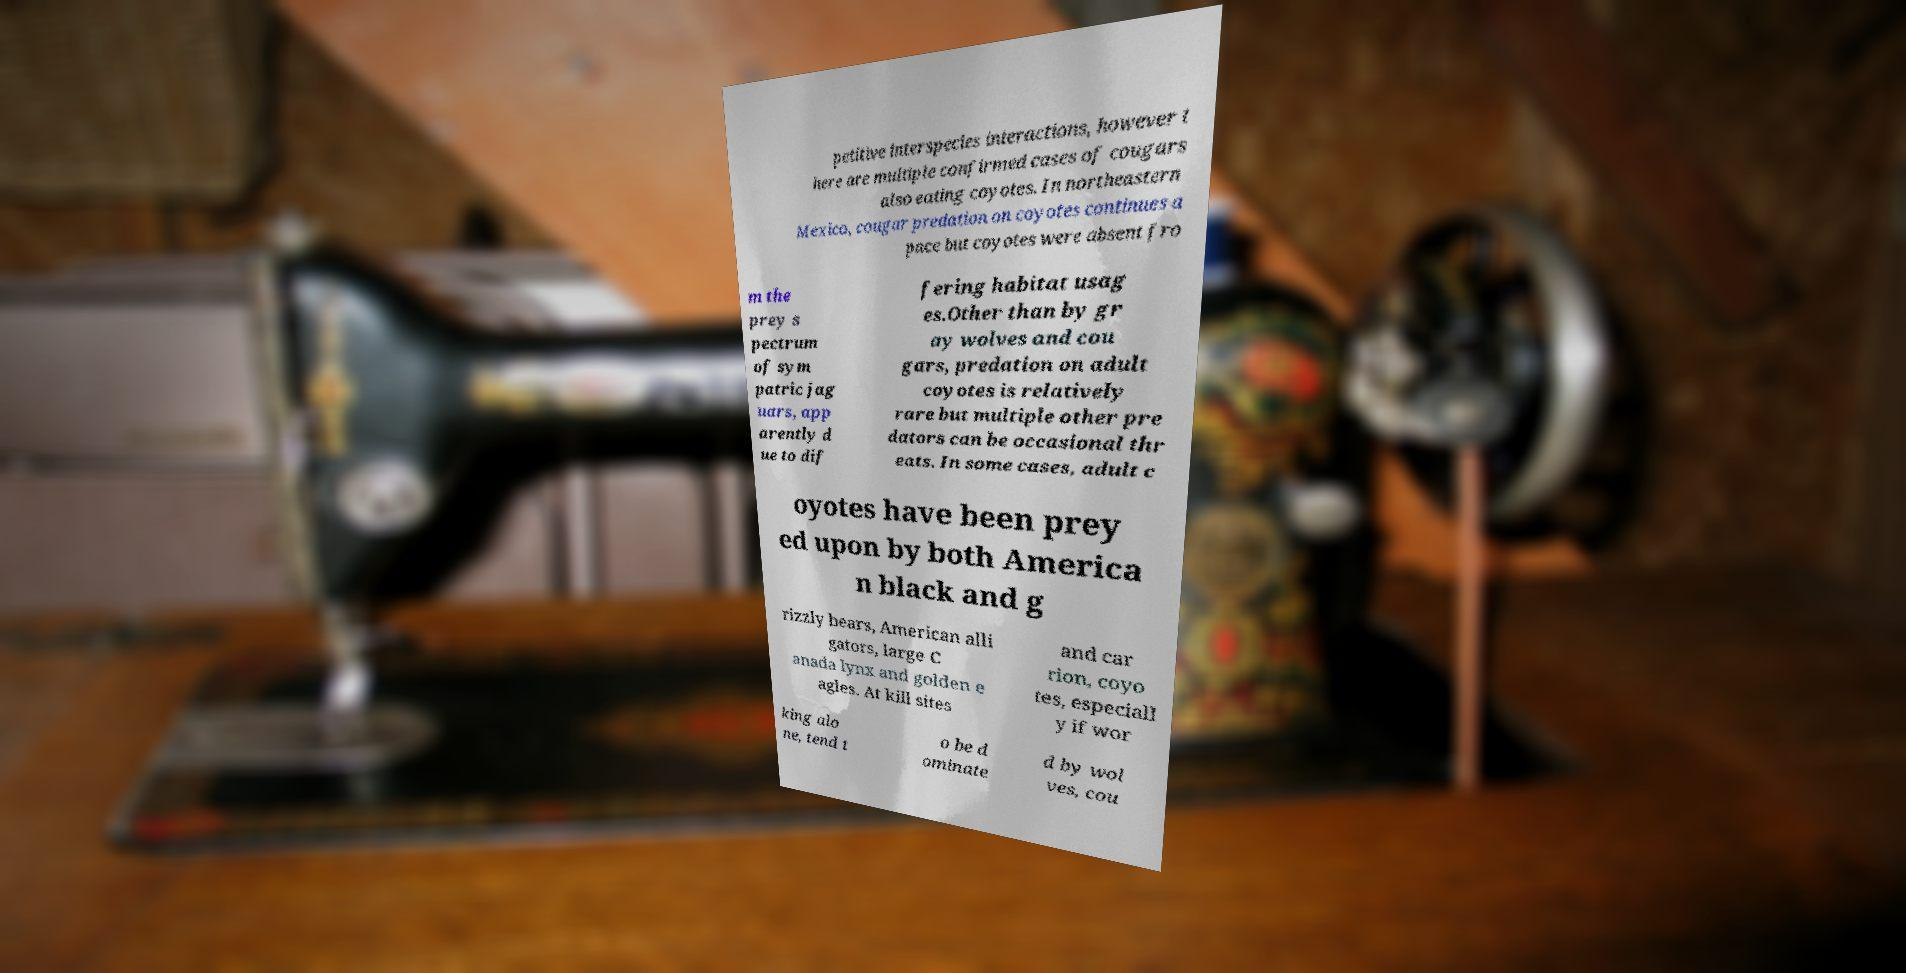For documentation purposes, I need the text within this image transcribed. Could you provide that? petitive interspecies interactions, however t here are multiple confirmed cases of cougars also eating coyotes. In northeastern Mexico, cougar predation on coyotes continues a pace but coyotes were absent fro m the prey s pectrum of sym patric jag uars, app arently d ue to dif fering habitat usag es.Other than by gr ay wolves and cou gars, predation on adult coyotes is relatively rare but multiple other pre dators can be occasional thr eats. In some cases, adult c oyotes have been prey ed upon by both America n black and g rizzly bears, American alli gators, large C anada lynx and golden e agles. At kill sites and car rion, coyo tes, especiall y if wor king alo ne, tend t o be d ominate d by wol ves, cou 